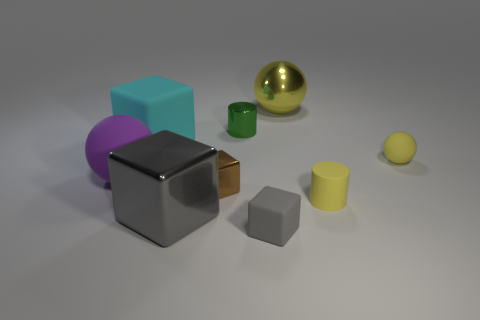Are there any big gray matte objects of the same shape as the cyan thing?
Offer a very short reply. No. There is a gray object that is behind the gray matte cube; is its shape the same as the yellow matte object that is behind the purple rubber ball?
Give a very brief answer. No. What is the material of the yellow object that is the same size as the purple rubber ball?
Provide a succinct answer. Metal. How many other objects are there of the same material as the tiny yellow cylinder?
Provide a short and direct response. 4. What shape is the large metallic object behind the big gray metal cube to the right of the cyan object?
Provide a short and direct response. Sphere. What number of objects are big rubber objects or tiny matte objects behind the yellow cylinder?
Provide a short and direct response. 3. How many other things are the same color as the metallic ball?
Give a very brief answer. 2. What number of red objects are big rubber blocks or tiny metal blocks?
Keep it short and to the point. 0. There is a matte ball that is to the left of the gray cube that is behind the gray rubber thing; are there any purple matte things on the right side of it?
Your answer should be very brief. No. Are there any other things that are the same size as the metal cylinder?
Ensure brevity in your answer.  Yes. 